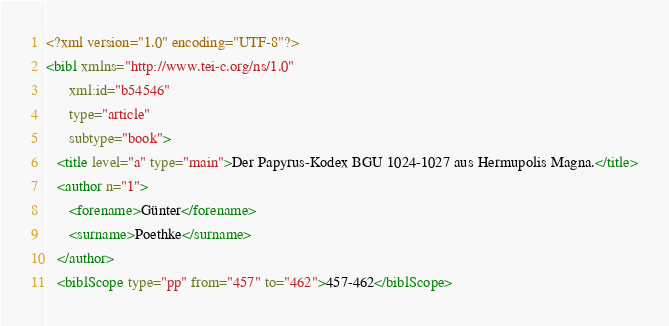Convert code to text. <code><loc_0><loc_0><loc_500><loc_500><_XML_><?xml version="1.0" encoding="UTF-8"?>
<bibl xmlns="http://www.tei-c.org/ns/1.0"
      xml:id="b54546"
      type="article"
      subtype="book">
   <title level="a" type="main">Der Papyrus-Kodex BGU 1024-1027 aus Hermupolis Magna.</title>
   <author n="1">
      <forename>Günter</forename>
      <surname>Poethke</surname>
   </author>
   <biblScope type="pp" from="457" to="462">457-462</biblScope></code> 